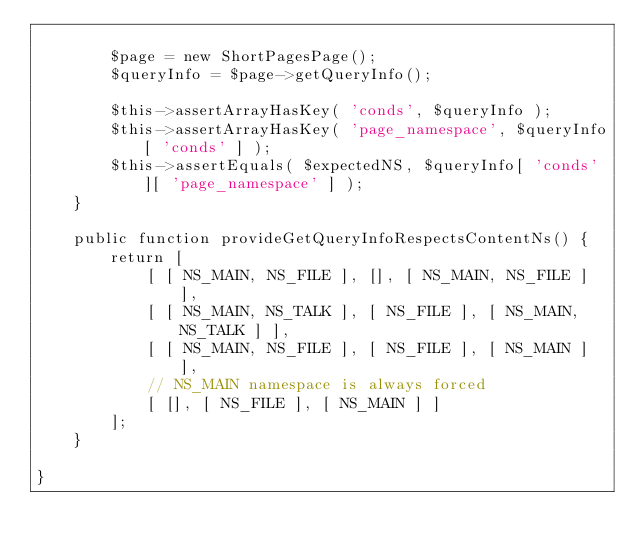Convert code to text. <code><loc_0><loc_0><loc_500><loc_500><_PHP_>
		$page = new ShortPagesPage();
		$queryInfo = $page->getQueryInfo();

		$this->assertArrayHasKey( 'conds', $queryInfo );
		$this->assertArrayHasKey( 'page_namespace', $queryInfo[ 'conds' ] );
		$this->assertEquals( $expectedNS, $queryInfo[ 'conds' ][ 'page_namespace' ] );
	}

	public function provideGetQueryInfoRespectsContentNs() {
		return [
			[ [ NS_MAIN, NS_FILE ], [], [ NS_MAIN, NS_FILE ] ],
			[ [ NS_MAIN, NS_TALK ], [ NS_FILE ], [ NS_MAIN, NS_TALK ] ],
			[ [ NS_MAIN, NS_FILE ], [ NS_FILE ], [ NS_MAIN ] ],
			// NS_MAIN namespace is always forced
			[ [], [ NS_FILE ], [ NS_MAIN ] ]
		];
	}

}
</code> 